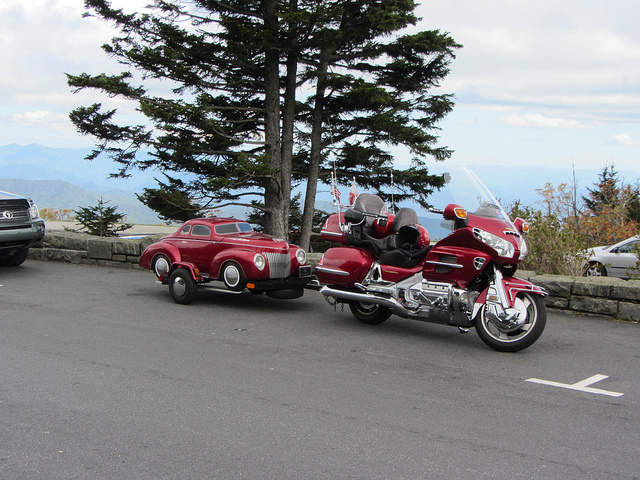What kind of vehicles are shown in this picture? In the image, there appears to be a classic red car that resembles a toy due to its small size, and next to it, there is a full-sized red motorcycle parked on asphalt.  Can you tell me more about the location where these vehicles are parked? While specific details of the location aren’t provided, the vehicles are parked at what seems to be a scenic overlook. There is a coniferous tree evident and a mountain range can be seen in the distance, suggesting a high altitude and possibly a tourist area known for its views. 